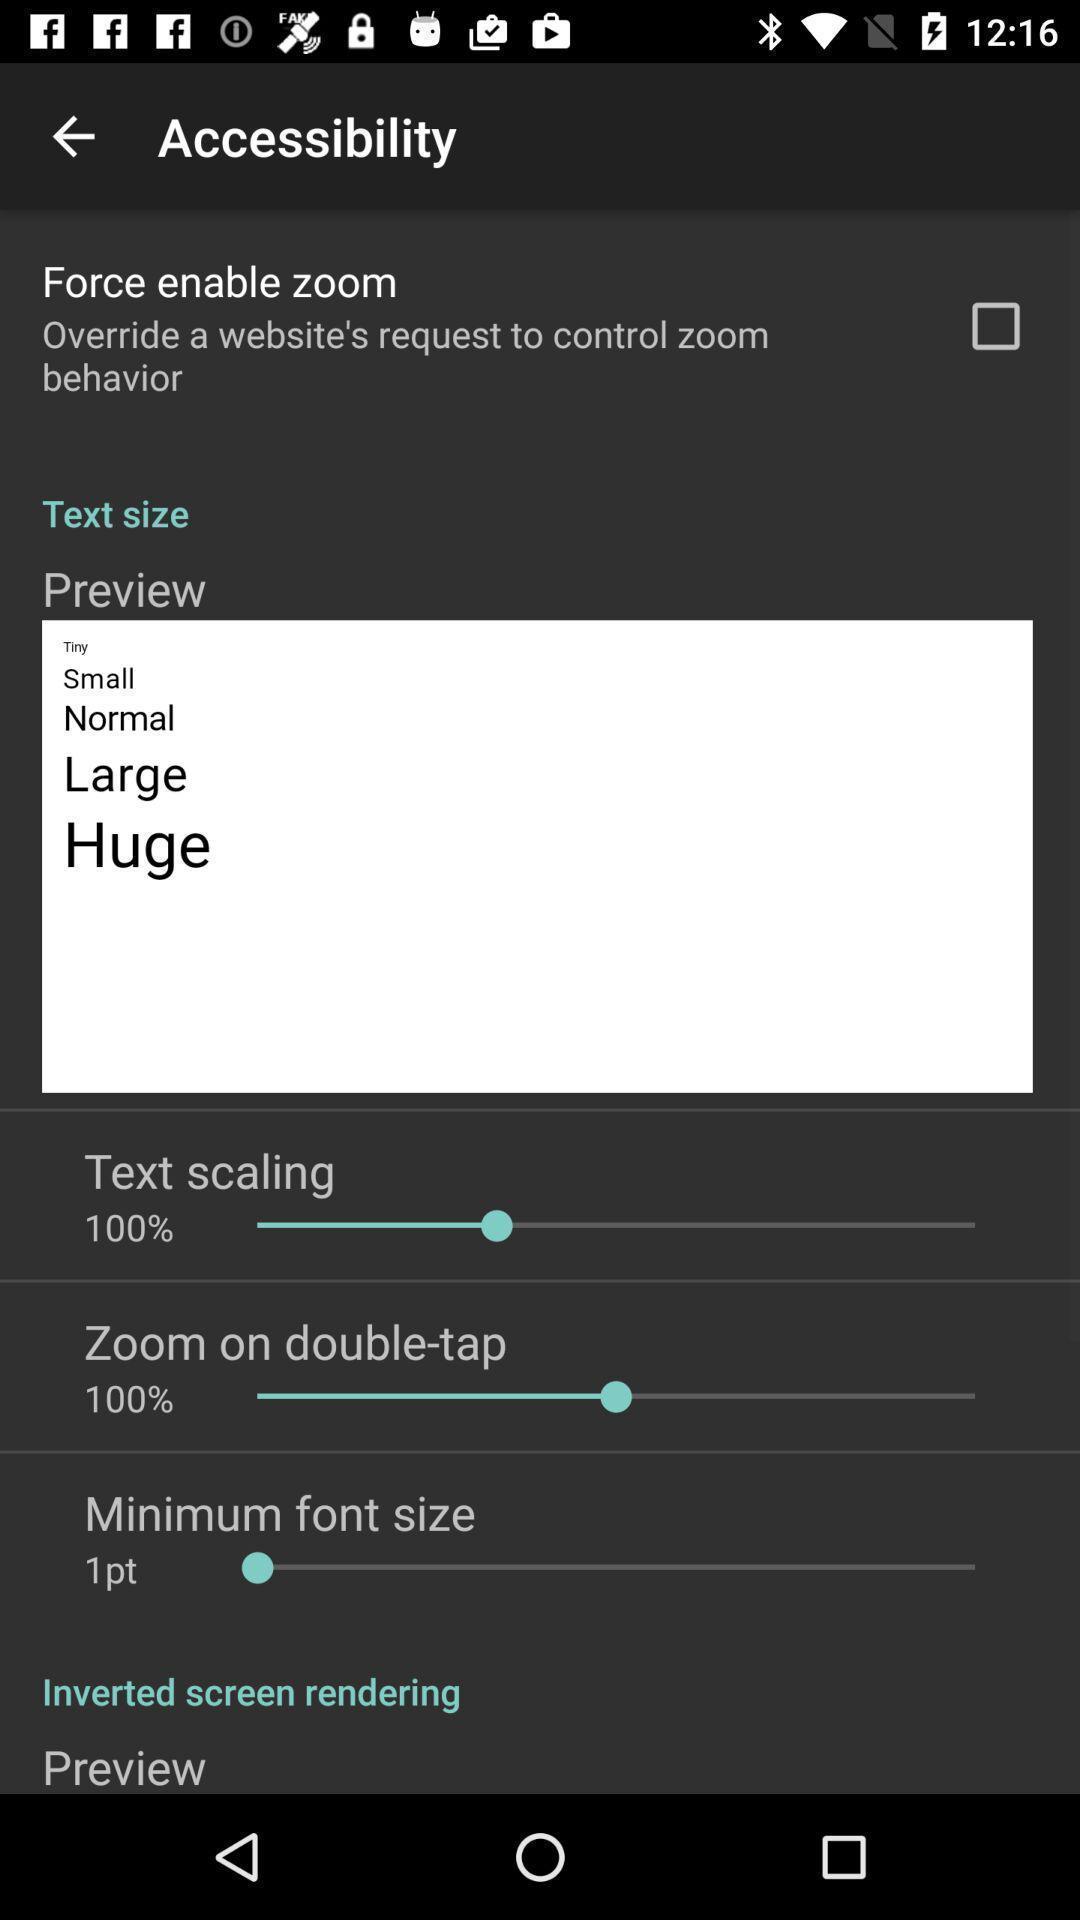Provide a detailed account of this screenshot. Setting page for setting text size of accessibility. 